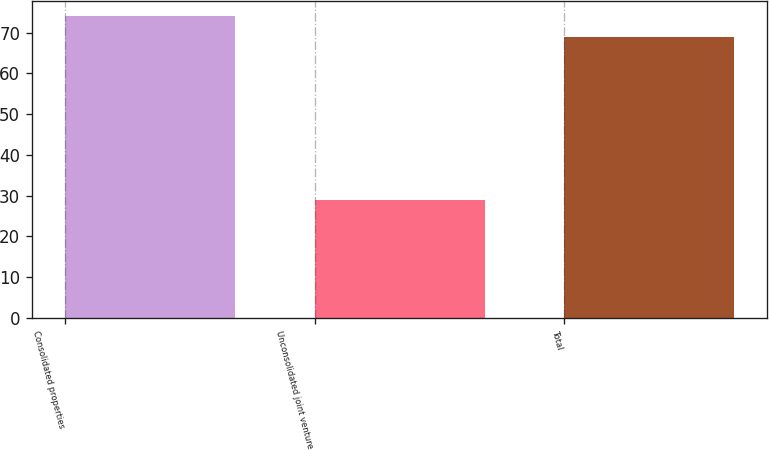Convert chart to OTSL. <chart><loc_0><loc_0><loc_500><loc_500><bar_chart><fcel>Consolidated properties<fcel>Unconsolidated joint venture<fcel>Total<nl><fcel>74<fcel>29<fcel>69<nl></chart> 